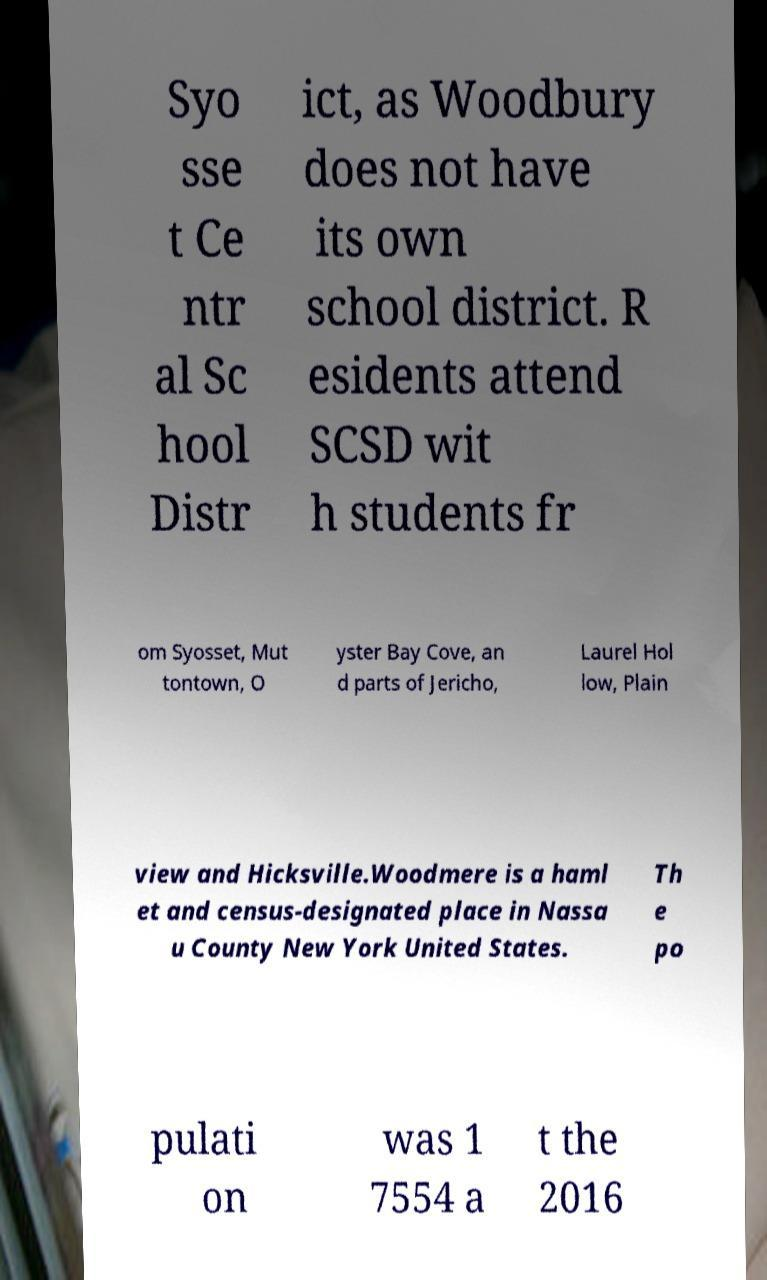Could you extract and type out the text from this image? Syo sse t Ce ntr al Sc hool Distr ict, as Woodbury does not have its own school district. R esidents attend SCSD wit h students fr om Syosset, Mut tontown, O yster Bay Cove, an d parts of Jericho, Laurel Hol low, Plain view and Hicksville.Woodmere is a haml et and census-designated place in Nassa u County New York United States. Th e po pulati on was 1 7554 a t the 2016 